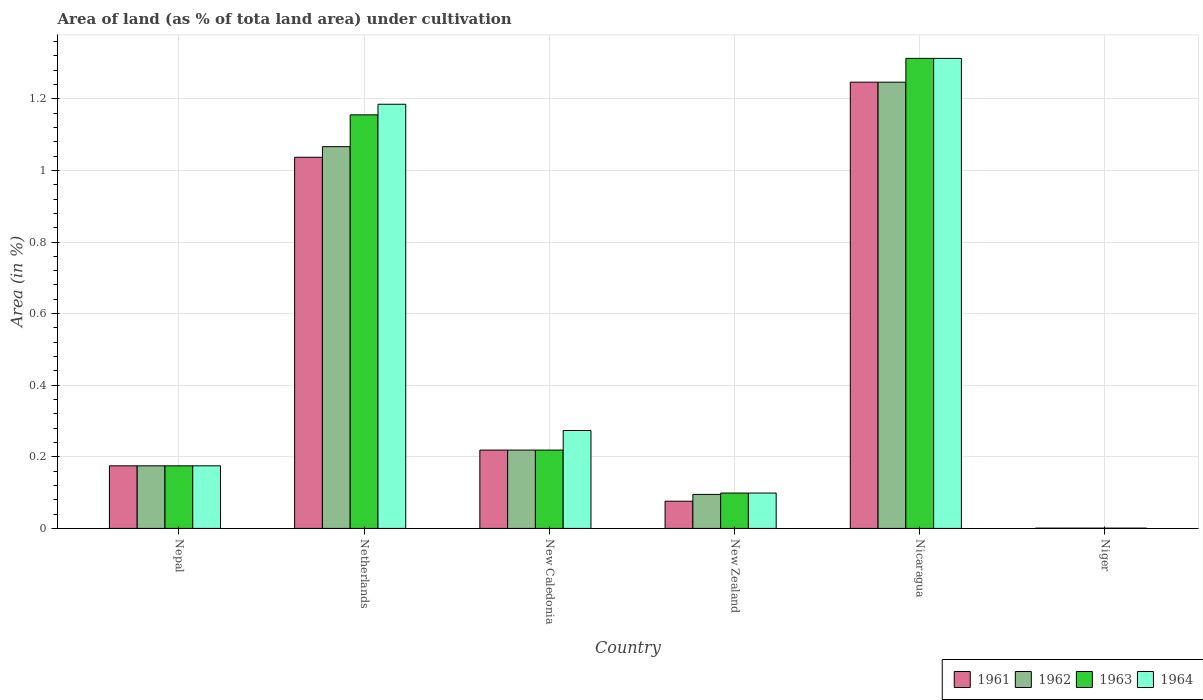How many groups of bars are there?
Make the answer very short. 6. Are the number of bars on each tick of the X-axis equal?
Ensure brevity in your answer.  Yes. How many bars are there on the 6th tick from the left?
Give a very brief answer. 4. How many bars are there on the 5th tick from the right?
Your answer should be compact. 4. What is the label of the 6th group of bars from the left?
Ensure brevity in your answer.  Niger. In how many cases, is the number of bars for a given country not equal to the number of legend labels?
Make the answer very short. 0. What is the percentage of land under cultivation in 1963 in New Caledonia?
Give a very brief answer. 0.22. Across all countries, what is the maximum percentage of land under cultivation in 1964?
Your answer should be compact. 1.31. Across all countries, what is the minimum percentage of land under cultivation in 1962?
Offer a very short reply. 0. In which country was the percentage of land under cultivation in 1961 maximum?
Give a very brief answer. Nicaragua. In which country was the percentage of land under cultivation in 1964 minimum?
Ensure brevity in your answer.  Niger. What is the total percentage of land under cultivation in 1963 in the graph?
Provide a short and direct response. 2.96. What is the difference between the percentage of land under cultivation in 1963 in Netherlands and that in New Caledonia?
Ensure brevity in your answer.  0.94. What is the difference between the percentage of land under cultivation in 1962 in Niger and the percentage of land under cultivation in 1961 in Nicaragua?
Give a very brief answer. -1.25. What is the average percentage of land under cultivation in 1962 per country?
Your response must be concise. 0.47. What is the difference between the percentage of land under cultivation of/in 1963 and percentage of land under cultivation of/in 1964 in New Caledonia?
Offer a very short reply. -0.05. What is the ratio of the percentage of land under cultivation in 1964 in Netherlands to that in New Zealand?
Make the answer very short. 12. Is the difference between the percentage of land under cultivation in 1963 in Nepal and New Caledonia greater than the difference between the percentage of land under cultivation in 1964 in Nepal and New Caledonia?
Your answer should be compact. Yes. What is the difference between the highest and the second highest percentage of land under cultivation in 1964?
Give a very brief answer. -1.04. What is the difference between the highest and the lowest percentage of land under cultivation in 1963?
Offer a very short reply. 1.31. In how many countries, is the percentage of land under cultivation in 1963 greater than the average percentage of land under cultivation in 1963 taken over all countries?
Make the answer very short. 2. What does the 1st bar from the right in Netherlands represents?
Keep it short and to the point. 1964. Is it the case that in every country, the sum of the percentage of land under cultivation in 1962 and percentage of land under cultivation in 1964 is greater than the percentage of land under cultivation in 1963?
Make the answer very short. Yes. How many bars are there?
Your answer should be very brief. 24. What is the difference between two consecutive major ticks on the Y-axis?
Keep it short and to the point. 0.2. Does the graph contain grids?
Provide a short and direct response. Yes. How many legend labels are there?
Offer a terse response. 4. How are the legend labels stacked?
Provide a succinct answer. Horizontal. What is the title of the graph?
Give a very brief answer. Area of land (as % of tota land area) under cultivation. Does "1986" appear as one of the legend labels in the graph?
Give a very brief answer. No. What is the label or title of the X-axis?
Keep it short and to the point. Country. What is the label or title of the Y-axis?
Offer a very short reply. Area (in %). What is the Area (in %) in 1961 in Nepal?
Offer a terse response. 0.17. What is the Area (in %) of 1962 in Nepal?
Your answer should be compact. 0.17. What is the Area (in %) of 1963 in Nepal?
Ensure brevity in your answer.  0.17. What is the Area (in %) in 1964 in Nepal?
Give a very brief answer. 0.17. What is the Area (in %) of 1961 in Netherlands?
Keep it short and to the point. 1.04. What is the Area (in %) in 1962 in Netherlands?
Your answer should be very brief. 1.07. What is the Area (in %) of 1963 in Netherlands?
Your answer should be very brief. 1.16. What is the Area (in %) of 1964 in Netherlands?
Your answer should be compact. 1.18. What is the Area (in %) of 1961 in New Caledonia?
Your answer should be very brief. 0.22. What is the Area (in %) in 1962 in New Caledonia?
Your answer should be compact. 0.22. What is the Area (in %) of 1963 in New Caledonia?
Ensure brevity in your answer.  0.22. What is the Area (in %) in 1964 in New Caledonia?
Provide a short and direct response. 0.27. What is the Area (in %) of 1961 in New Zealand?
Your answer should be very brief. 0.08. What is the Area (in %) in 1962 in New Zealand?
Your answer should be very brief. 0.09. What is the Area (in %) of 1963 in New Zealand?
Make the answer very short. 0.1. What is the Area (in %) of 1964 in New Zealand?
Provide a succinct answer. 0.1. What is the Area (in %) in 1961 in Nicaragua?
Ensure brevity in your answer.  1.25. What is the Area (in %) in 1962 in Nicaragua?
Provide a succinct answer. 1.25. What is the Area (in %) in 1963 in Nicaragua?
Provide a succinct answer. 1.31. What is the Area (in %) in 1964 in Nicaragua?
Your answer should be compact. 1.31. What is the Area (in %) in 1961 in Niger?
Offer a terse response. 0. What is the Area (in %) in 1962 in Niger?
Offer a very short reply. 0. What is the Area (in %) of 1963 in Niger?
Your response must be concise. 0. What is the Area (in %) in 1964 in Niger?
Keep it short and to the point. 0. Across all countries, what is the maximum Area (in %) in 1961?
Offer a very short reply. 1.25. Across all countries, what is the maximum Area (in %) in 1962?
Provide a short and direct response. 1.25. Across all countries, what is the maximum Area (in %) of 1963?
Ensure brevity in your answer.  1.31. Across all countries, what is the maximum Area (in %) in 1964?
Provide a short and direct response. 1.31. Across all countries, what is the minimum Area (in %) of 1961?
Keep it short and to the point. 0. Across all countries, what is the minimum Area (in %) in 1962?
Ensure brevity in your answer.  0. Across all countries, what is the minimum Area (in %) of 1963?
Make the answer very short. 0. Across all countries, what is the minimum Area (in %) of 1964?
Your answer should be compact. 0. What is the total Area (in %) in 1961 in the graph?
Make the answer very short. 2.75. What is the total Area (in %) of 1962 in the graph?
Offer a terse response. 2.8. What is the total Area (in %) of 1963 in the graph?
Your response must be concise. 2.96. What is the total Area (in %) in 1964 in the graph?
Keep it short and to the point. 3.05. What is the difference between the Area (in %) in 1961 in Nepal and that in Netherlands?
Make the answer very short. -0.86. What is the difference between the Area (in %) in 1962 in Nepal and that in Netherlands?
Offer a terse response. -0.89. What is the difference between the Area (in %) in 1963 in Nepal and that in Netherlands?
Ensure brevity in your answer.  -0.98. What is the difference between the Area (in %) in 1964 in Nepal and that in Netherlands?
Offer a terse response. -1.01. What is the difference between the Area (in %) in 1961 in Nepal and that in New Caledonia?
Make the answer very short. -0.04. What is the difference between the Area (in %) of 1962 in Nepal and that in New Caledonia?
Your response must be concise. -0.04. What is the difference between the Area (in %) in 1963 in Nepal and that in New Caledonia?
Give a very brief answer. -0.04. What is the difference between the Area (in %) in 1964 in Nepal and that in New Caledonia?
Provide a succinct answer. -0.1. What is the difference between the Area (in %) of 1961 in Nepal and that in New Zealand?
Offer a terse response. 0.1. What is the difference between the Area (in %) of 1962 in Nepal and that in New Zealand?
Your answer should be compact. 0.08. What is the difference between the Area (in %) of 1963 in Nepal and that in New Zealand?
Your answer should be compact. 0.08. What is the difference between the Area (in %) of 1964 in Nepal and that in New Zealand?
Keep it short and to the point. 0.08. What is the difference between the Area (in %) in 1961 in Nepal and that in Nicaragua?
Offer a terse response. -1.07. What is the difference between the Area (in %) in 1962 in Nepal and that in Nicaragua?
Offer a very short reply. -1.07. What is the difference between the Area (in %) of 1963 in Nepal and that in Nicaragua?
Provide a short and direct response. -1.14. What is the difference between the Area (in %) of 1964 in Nepal and that in Nicaragua?
Keep it short and to the point. -1.14. What is the difference between the Area (in %) of 1961 in Nepal and that in Niger?
Your response must be concise. 0.17. What is the difference between the Area (in %) of 1962 in Nepal and that in Niger?
Make the answer very short. 0.17. What is the difference between the Area (in %) of 1963 in Nepal and that in Niger?
Ensure brevity in your answer.  0.17. What is the difference between the Area (in %) in 1964 in Nepal and that in Niger?
Offer a terse response. 0.17. What is the difference between the Area (in %) in 1961 in Netherlands and that in New Caledonia?
Make the answer very short. 0.82. What is the difference between the Area (in %) of 1962 in Netherlands and that in New Caledonia?
Your answer should be compact. 0.85. What is the difference between the Area (in %) of 1963 in Netherlands and that in New Caledonia?
Keep it short and to the point. 0.94. What is the difference between the Area (in %) of 1964 in Netherlands and that in New Caledonia?
Your response must be concise. 0.91. What is the difference between the Area (in %) in 1961 in Netherlands and that in New Zealand?
Your response must be concise. 0.96. What is the difference between the Area (in %) in 1962 in Netherlands and that in New Zealand?
Give a very brief answer. 0.97. What is the difference between the Area (in %) in 1963 in Netherlands and that in New Zealand?
Keep it short and to the point. 1.06. What is the difference between the Area (in %) of 1964 in Netherlands and that in New Zealand?
Your response must be concise. 1.09. What is the difference between the Area (in %) in 1961 in Netherlands and that in Nicaragua?
Offer a very short reply. -0.21. What is the difference between the Area (in %) in 1962 in Netherlands and that in Nicaragua?
Keep it short and to the point. -0.18. What is the difference between the Area (in %) in 1963 in Netherlands and that in Nicaragua?
Your answer should be very brief. -0.16. What is the difference between the Area (in %) in 1964 in Netherlands and that in Nicaragua?
Your response must be concise. -0.13. What is the difference between the Area (in %) of 1961 in Netherlands and that in Niger?
Keep it short and to the point. 1.04. What is the difference between the Area (in %) in 1962 in Netherlands and that in Niger?
Offer a very short reply. 1.07. What is the difference between the Area (in %) in 1963 in Netherlands and that in Niger?
Keep it short and to the point. 1.15. What is the difference between the Area (in %) in 1964 in Netherlands and that in Niger?
Offer a terse response. 1.18. What is the difference between the Area (in %) of 1961 in New Caledonia and that in New Zealand?
Your answer should be very brief. 0.14. What is the difference between the Area (in %) in 1962 in New Caledonia and that in New Zealand?
Offer a very short reply. 0.12. What is the difference between the Area (in %) in 1963 in New Caledonia and that in New Zealand?
Keep it short and to the point. 0.12. What is the difference between the Area (in %) in 1964 in New Caledonia and that in New Zealand?
Provide a succinct answer. 0.17. What is the difference between the Area (in %) in 1961 in New Caledonia and that in Nicaragua?
Offer a terse response. -1.03. What is the difference between the Area (in %) of 1962 in New Caledonia and that in Nicaragua?
Provide a short and direct response. -1.03. What is the difference between the Area (in %) of 1963 in New Caledonia and that in Nicaragua?
Make the answer very short. -1.09. What is the difference between the Area (in %) in 1964 in New Caledonia and that in Nicaragua?
Provide a succinct answer. -1.04. What is the difference between the Area (in %) in 1961 in New Caledonia and that in Niger?
Ensure brevity in your answer.  0.22. What is the difference between the Area (in %) of 1962 in New Caledonia and that in Niger?
Give a very brief answer. 0.22. What is the difference between the Area (in %) in 1963 in New Caledonia and that in Niger?
Offer a terse response. 0.22. What is the difference between the Area (in %) in 1964 in New Caledonia and that in Niger?
Provide a succinct answer. 0.27. What is the difference between the Area (in %) of 1961 in New Zealand and that in Nicaragua?
Offer a very short reply. -1.17. What is the difference between the Area (in %) in 1962 in New Zealand and that in Nicaragua?
Ensure brevity in your answer.  -1.15. What is the difference between the Area (in %) of 1963 in New Zealand and that in Nicaragua?
Offer a terse response. -1.21. What is the difference between the Area (in %) of 1964 in New Zealand and that in Nicaragua?
Make the answer very short. -1.21. What is the difference between the Area (in %) of 1961 in New Zealand and that in Niger?
Keep it short and to the point. 0.08. What is the difference between the Area (in %) of 1962 in New Zealand and that in Niger?
Keep it short and to the point. 0.09. What is the difference between the Area (in %) in 1963 in New Zealand and that in Niger?
Your answer should be compact. 0.1. What is the difference between the Area (in %) of 1964 in New Zealand and that in Niger?
Offer a very short reply. 0.1. What is the difference between the Area (in %) in 1961 in Nicaragua and that in Niger?
Give a very brief answer. 1.25. What is the difference between the Area (in %) in 1962 in Nicaragua and that in Niger?
Make the answer very short. 1.25. What is the difference between the Area (in %) of 1963 in Nicaragua and that in Niger?
Offer a terse response. 1.31. What is the difference between the Area (in %) in 1964 in Nicaragua and that in Niger?
Your answer should be very brief. 1.31. What is the difference between the Area (in %) in 1961 in Nepal and the Area (in %) in 1962 in Netherlands?
Offer a very short reply. -0.89. What is the difference between the Area (in %) of 1961 in Nepal and the Area (in %) of 1963 in Netherlands?
Keep it short and to the point. -0.98. What is the difference between the Area (in %) in 1961 in Nepal and the Area (in %) in 1964 in Netherlands?
Offer a very short reply. -1.01. What is the difference between the Area (in %) in 1962 in Nepal and the Area (in %) in 1963 in Netherlands?
Offer a terse response. -0.98. What is the difference between the Area (in %) of 1962 in Nepal and the Area (in %) of 1964 in Netherlands?
Make the answer very short. -1.01. What is the difference between the Area (in %) of 1963 in Nepal and the Area (in %) of 1964 in Netherlands?
Provide a short and direct response. -1.01. What is the difference between the Area (in %) of 1961 in Nepal and the Area (in %) of 1962 in New Caledonia?
Your answer should be compact. -0.04. What is the difference between the Area (in %) of 1961 in Nepal and the Area (in %) of 1963 in New Caledonia?
Your answer should be compact. -0.04. What is the difference between the Area (in %) in 1961 in Nepal and the Area (in %) in 1964 in New Caledonia?
Your response must be concise. -0.1. What is the difference between the Area (in %) in 1962 in Nepal and the Area (in %) in 1963 in New Caledonia?
Provide a short and direct response. -0.04. What is the difference between the Area (in %) in 1962 in Nepal and the Area (in %) in 1964 in New Caledonia?
Give a very brief answer. -0.1. What is the difference between the Area (in %) of 1963 in Nepal and the Area (in %) of 1964 in New Caledonia?
Your response must be concise. -0.1. What is the difference between the Area (in %) of 1961 in Nepal and the Area (in %) of 1962 in New Zealand?
Keep it short and to the point. 0.08. What is the difference between the Area (in %) in 1961 in Nepal and the Area (in %) in 1963 in New Zealand?
Provide a succinct answer. 0.08. What is the difference between the Area (in %) in 1961 in Nepal and the Area (in %) in 1964 in New Zealand?
Offer a terse response. 0.08. What is the difference between the Area (in %) of 1962 in Nepal and the Area (in %) of 1963 in New Zealand?
Ensure brevity in your answer.  0.08. What is the difference between the Area (in %) in 1962 in Nepal and the Area (in %) in 1964 in New Zealand?
Offer a terse response. 0.08. What is the difference between the Area (in %) of 1963 in Nepal and the Area (in %) of 1964 in New Zealand?
Provide a succinct answer. 0.08. What is the difference between the Area (in %) of 1961 in Nepal and the Area (in %) of 1962 in Nicaragua?
Your answer should be compact. -1.07. What is the difference between the Area (in %) of 1961 in Nepal and the Area (in %) of 1963 in Nicaragua?
Give a very brief answer. -1.14. What is the difference between the Area (in %) of 1961 in Nepal and the Area (in %) of 1964 in Nicaragua?
Ensure brevity in your answer.  -1.14. What is the difference between the Area (in %) of 1962 in Nepal and the Area (in %) of 1963 in Nicaragua?
Your answer should be very brief. -1.14. What is the difference between the Area (in %) in 1962 in Nepal and the Area (in %) in 1964 in Nicaragua?
Your response must be concise. -1.14. What is the difference between the Area (in %) in 1963 in Nepal and the Area (in %) in 1964 in Nicaragua?
Ensure brevity in your answer.  -1.14. What is the difference between the Area (in %) in 1961 in Nepal and the Area (in %) in 1962 in Niger?
Ensure brevity in your answer.  0.17. What is the difference between the Area (in %) of 1961 in Nepal and the Area (in %) of 1963 in Niger?
Your response must be concise. 0.17. What is the difference between the Area (in %) of 1961 in Nepal and the Area (in %) of 1964 in Niger?
Provide a succinct answer. 0.17. What is the difference between the Area (in %) in 1962 in Nepal and the Area (in %) in 1963 in Niger?
Provide a succinct answer. 0.17. What is the difference between the Area (in %) of 1962 in Nepal and the Area (in %) of 1964 in Niger?
Your answer should be compact. 0.17. What is the difference between the Area (in %) of 1963 in Nepal and the Area (in %) of 1964 in Niger?
Offer a very short reply. 0.17. What is the difference between the Area (in %) in 1961 in Netherlands and the Area (in %) in 1962 in New Caledonia?
Keep it short and to the point. 0.82. What is the difference between the Area (in %) in 1961 in Netherlands and the Area (in %) in 1963 in New Caledonia?
Provide a short and direct response. 0.82. What is the difference between the Area (in %) in 1961 in Netherlands and the Area (in %) in 1964 in New Caledonia?
Offer a very short reply. 0.76. What is the difference between the Area (in %) in 1962 in Netherlands and the Area (in %) in 1963 in New Caledonia?
Keep it short and to the point. 0.85. What is the difference between the Area (in %) of 1962 in Netherlands and the Area (in %) of 1964 in New Caledonia?
Offer a very short reply. 0.79. What is the difference between the Area (in %) of 1963 in Netherlands and the Area (in %) of 1964 in New Caledonia?
Your answer should be very brief. 0.88. What is the difference between the Area (in %) of 1961 in Netherlands and the Area (in %) of 1962 in New Zealand?
Ensure brevity in your answer.  0.94. What is the difference between the Area (in %) in 1961 in Netherlands and the Area (in %) in 1963 in New Zealand?
Offer a terse response. 0.94. What is the difference between the Area (in %) of 1961 in Netherlands and the Area (in %) of 1964 in New Zealand?
Keep it short and to the point. 0.94. What is the difference between the Area (in %) of 1962 in Netherlands and the Area (in %) of 1963 in New Zealand?
Make the answer very short. 0.97. What is the difference between the Area (in %) of 1962 in Netherlands and the Area (in %) of 1964 in New Zealand?
Your answer should be compact. 0.97. What is the difference between the Area (in %) of 1963 in Netherlands and the Area (in %) of 1964 in New Zealand?
Provide a succinct answer. 1.06. What is the difference between the Area (in %) in 1961 in Netherlands and the Area (in %) in 1962 in Nicaragua?
Provide a short and direct response. -0.21. What is the difference between the Area (in %) in 1961 in Netherlands and the Area (in %) in 1963 in Nicaragua?
Provide a short and direct response. -0.28. What is the difference between the Area (in %) of 1961 in Netherlands and the Area (in %) of 1964 in Nicaragua?
Your response must be concise. -0.28. What is the difference between the Area (in %) of 1962 in Netherlands and the Area (in %) of 1963 in Nicaragua?
Your answer should be very brief. -0.25. What is the difference between the Area (in %) of 1962 in Netherlands and the Area (in %) of 1964 in Nicaragua?
Your response must be concise. -0.25. What is the difference between the Area (in %) in 1963 in Netherlands and the Area (in %) in 1964 in Nicaragua?
Your answer should be compact. -0.16. What is the difference between the Area (in %) of 1961 in Netherlands and the Area (in %) of 1962 in Niger?
Keep it short and to the point. 1.04. What is the difference between the Area (in %) in 1961 in Netherlands and the Area (in %) in 1963 in Niger?
Provide a succinct answer. 1.04. What is the difference between the Area (in %) in 1961 in Netherlands and the Area (in %) in 1964 in Niger?
Provide a short and direct response. 1.04. What is the difference between the Area (in %) in 1962 in Netherlands and the Area (in %) in 1963 in Niger?
Give a very brief answer. 1.07. What is the difference between the Area (in %) in 1962 in Netherlands and the Area (in %) in 1964 in Niger?
Give a very brief answer. 1.07. What is the difference between the Area (in %) of 1963 in Netherlands and the Area (in %) of 1964 in Niger?
Make the answer very short. 1.15. What is the difference between the Area (in %) in 1961 in New Caledonia and the Area (in %) in 1962 in New Zealand?
Ensure brevity in your answer.  0.12. What is the difference between the Area (in %) in 1961 in New Caledonia and the Area (in %) in 1963 in New Zealand?
Offer a terse response. 0.12. What is the difference between the Area (in %) in 1961 in New Caledonia and the Area (in %) in 1964 in New Zealand?
Offer a very short reply. 0.12. What is the difference between the Area (in %) of 1962 in New Caledonia and the Area (in %) of 1963 in New Zealand?
Ensure brevity in your answer.  0.12. What is the difference between the Area (in %) of 1962 in New Caledonia and the Area (in %) of 1964 in New Zealand?
Make the answer very short. 0.12. What is the difference between the Area (in %) in 1963 in New Caledonia and the Area (in %) in 1964 in New Zealand?
Make the answer very short. 0.12. What is the difference between the Area (in %) of 1961 in New Caledonia and the Area (in %) of 1962 in Nicaragua?
Your response must be concise. -1.03. What is the difference between the Area (in %) of 1961 in New Caledonia and the Area (in %) of 1963 in Nicaragua?
Provide a succinct answer. -1.09. What is the difference between the Area (in %) in 1961 in New Caledonia and the Area (in %) in 1964 in Nicaragua?
Your response must be concise. -1.09. What is the difference between the Area (in %) in 1962 in New Caledonia and the Area (in %) in 1963 in Nicaragua?
Your response must be concise. -1.09. What is the difference between the Area (in %) in 1962 in New Caledonia and the Area (in %) in 1964 in Nicaragua?
Offer a terse response. -1.09. What is the difference between the Area (in %) of 1963 in New Caledonia and the Area (in %) of 1964 in Nicaragua?
Make the answer very short. -1.09. What is the difference between the Area (in %) of 1961 in New Caledonia and the Area (in %) of 1962 in Niger?
Provide a short and direct response. 0.22. What is the difference between the Area (in %) of 1961 in New Caledonia and the Area (in %) of 1963 in Niger?
Keep it short and to the point. 0.22. What is the difference between the Area (in %) of 1961 in New Caledonia and the Area (in %) of 1964 in Niger?
Your answer should be very brief. 0.22. What is the difference between the Area (in %) in 1962 in New Caledonia and the Area (in %) in 1963 in Niger?
Ensure brevity in your answer.  0.22. What is the difference between the Area (in %) in 1962 in New Caledonia and the Area (in %) in 1964 in Niger?
Offer a terse response. 0.22. What is the difference between the Area (in %) of 1963 in New Caledonia and the Area (in %) of 1964 in Niger?
Your response must be concise. 0.22. What is the difference between the Area (in %) of 1961 in New Zealand and the Area (in %) of 1962 in Nicaragua?
Ensure brevity in your answer.  -1.17. What is the difference between the Area (in %) of 1961 in New Zealand and the Area (in %) of 1963 in Nicaragua?
Make the answer very short. -1.24. What is the difference between the Area (in %) in 1961 in New Zealand and the Area (in %) in 1964 in Nicaragua?
Provide a succinct answer. -1.24. What is the difference between the Area (in %) in 1962 in New Zealand and the Area (in %) in 1963 in Nicaragua?
Give a very brief answer. -1.22. What is the difference between the Area (in %) in 1962 in New Zealand and the Area (in %) in 1964 in Nicaragua?
Ensure brevity in your answer.  -1.22. What is the difference between the Area (in %) in 1963 in New Zealand and the Area (in %) in 1964 in Nicaragua?
Keep it short and to the point. -1.21. What is the difference between the Area (in %) of 1961 in New Zealand and the Area (in %) of 1962 in Niger?
Ensure brevity in your answer.  0.08. What is the difference between the Area (in %) of 1961 in New Zealand and the Area (in %) of 1963 in Niger?
Give a very brief answer. 0.08. What is the difference between the Area (in %) in 1961 in New Zealand and the Area (in %) in 1964 in Niger?
Your answer should be very brief. 0.08. What is the difference between the Area (in %) in 1962 in New Zealand and the Area (in %) in 1963 in Niger?
Offer a terse response. 0.09. What is the difference between the Area (in %) in 1962 in New Zealand and the Area (in %) in 1964 in Niger?
Provide a succinct answer. 0.09. What is the difference between the Area (in %) in 1963 in New Zealand and the Area (in %) in 1964 in Niger?
Offer a very short reply. 0.1. What is the difference between the Area (in %) of 1961 in Nicaragua and the Area (in %) of 1962 in Niger?
Make the answer very short. 1.25. What is the difference between the Area (in %) in 1961 in Nicaragua and the Area (in %) in 1963 in Niger?
Your response must be concise. 1.25. What is the difference between the Area (in %) in 1961 in Nicaragua and the Area (in %) in 1964 in Niger?
Offer a very short reply. 1.25. What is the difference between the Area (in %) of 1962 in Nicaragua and the Area (in %) of 1963 in Niger?
Your answer should be compact. 1.25. What is the difference between the Area (in %) of 1962 in Nicaragua and the Area (in %) of 1964 in Niger?
Provide a succinct answer. 1.25. What is the difference between the Area (in %) of 1963 in Nicaragua and the Area (in %) of 1964 in Niger?
Make the answer very short. 1.31. What is the average Area (in %) in 1961 per country?
Provide a succinct answer. 0.46. What is the average Area (in %) of 1962 per country?
Your answer should be compact. 0.47. What is the average Area (in %) in 1963 per country?
Keep it short and to the point. 0.49. What is the average Area (in %) of 1964 per country?
Ensure brevity in your answer.  0.51. What is the difference between the Area (in %) of 1961 and Area (in %) of 1962 in Nepal?
Make the answer very short. 0. What is the difference between the Area (in %) in 1961 and Area (in %) in 1964 in Nepal?
Keep it short and to the point. 0. What is the difference between the Area (in %) of 1963 and Area (in %) of 1964 in Nepal?
Ensure brevity in your answer.  0. What is the difference between the Area (in %) of 1961 and Area (in %) of 1962 in Netherlands?
Offer a very short reply. -0.03. What is the difference between the Area (in %) in 1961 and Area (in %) in 1963 in Netherlands?
Provide a short and direct response. -0.12. What is the difference between the Area (in %) in 1961 and Area (in %) in 1964 in Netherlands?
Offer a very short reply. -0.15. What is the difference between the Area (in %) in 1962 and Area (in %) in 1963 in Netherlands?
Offer a very short reply. -0.09. What is the difference between the Area (in %) in 1962 and Area (in %) in 1964 in Netherlands?
Your response must be concise. -0.12. What is the difference between the Area (in %) of 1963 and Area (in %) of 1964 in Netherlands?
Your answer should be compact. -0.03. What is the difference between the Area (in %) of 1961 and Area (in %) of 1963 in New Caledonia?
Give a very brief answer. 0. What is the difference between the Area (in %) of 1961 and Area (in %) of 1964 in New Caledonia?
Keep it short and to the point. -0.05. What is the difference between the Area (in %) of 1962 and Area (in %) of 1963 in New Caledonia?
Your response must be concise. 0. What is the difference between the Area (in %) in 1962 and Area (in %) in 1964 in New Caledonia?
Offer a very short reply. -0.05. What is the difference between the Area (in %) in 1963 and Area (in %) in 1964 in New Caledonia?
Your answer should be compact. -0.05. What is the difference between the Area (in %) in 1961 and Area (in %) in 1962 in New Zealand?
Keep it short and to the point. -0.02. What is the difference between the Area (in %) of 1961 and Area (in %) of 1963 in New Zealand?
Your answer should be very brief. -0.02. What is the difference between the Area (in %) of 1961 and Area (in %) of 1964 in New Zealand?
Keep it short and to the point. -0.02. What is the difference between the Area (in %) of 1962 and Area (in %) of 1963 in New Zealand?
Offer a terse response. -0. What is the difference between the Area (in %) in 1962 and Area (in %) in 1964 in New Zealand?
Provide a short and direct response. -0. What is the difference between the Area (in %) of 1963 and Area (in %) of 1964 in New Zealand?
Offer a very short reply. 0. What is the difference between the Area (in %) of 1961 and Area (in %) of 1962 in Nicaragua?
Your response must be concise. 0. What is the difference between the Area (in %) of 1961 and Area (in %) of 1963 in Nicaragua?
Offer a very short reply. -0.07. What is the difference between the Area (in %) of 1961 and Area (in %) of 1964 in Nicaragua?
Provide a short and direct response. -0.07. What is the difference between the Area (in %) of 1962 and Area (in %) of 1963 in Nicaragua?
Offer a terse response. -0.07. What is the difference between the Area (in %) in 1962 and Area (in %) in 1964 in Nicaragua?
Your response must be concise. -0.07. What is the difference between the Area (in %) of 1961 and Area (in %) of 1963 in Niger?
Your response must be concise. 0. What is the difference between the Area (in %) in 1962 and Area (in %) in 1963 in Niger?
Make the answer very short. 0. What is the ratio of the Area (in %) of 1961 in Nepal to that in Netherlands?
Offer a very short reply. 0.17. What is the ratio of the Area (in %) of 1962 in Nepal to that in Netherlands?
Provide a short and direct response. 0.16. What is the ratio of the Area (in %) in 1963 in Nepal to that in Netherlands?
Give a very brief answer. 0.15. What is the ratio of the Area (in %) in 1964 in Nepal to that in Netherlands?
Ensure brevity in your answer.  0.15. What is the ratio of the Area (in %) in 1961 in Nepal to that in New Caledonia?
Your answer should be compact. 0.8. What is the ratio of the Area (in %) of 1962 in Nepal to that in New Caledonia?
Your answer should be compact. 0.8. What is the ratio of the Area (in %) in 1963 in Nepal to that in New Caledonia?
Offer a very short reply. 0.8. What is the ratio of the Area (in %) in 1964 in Nepal to that in New Caledonia?
Give a very brief answer. 0.64. What is the ratio of the Area (in %) in 1961 in Nepal to that in New Zealand?
Your answer should be compact. 2.3. What is the ratio of the Area (in %) of 1962 in Nepal to that in New Zealand?
Keep it short and to the point. 1.84. What is the ratio of the Area (in %) of 1963 in Nepal to that in New Zealand?
Your answer should be compact. 1.77. What is the ratio of the Area (in %) in 1964 in Nepal to that in New Zealand?
Ensure brevity in your answer.  1.77. What is the ratio of the Area (in %) in 1961 in Nepal to that in Nicaragua?
Give a very brief answer. 0.14. What is the ratio of the Area (in %) of 1962 in Nepal to that in Nicaragua?
Give a very brief answer. 0.14. What is the ratio of the Area (in %) of 1963 in Nepal to that in Nicaragua?
Keep it short and to the point. 0.13. What is the ratio of the Area (in %) of 1964 in Nepal to that in Nicaragua?
Provide a short and direct response. 0.13. What is the ratio of the Area (in %) in 1961 in Nepal to that in Niger?
Offer a very short reply. 221.45. What is the ratio of the Area (in %) of 1962 in Nepal to that in Niger?
Make the answer very short. 221.45. What is the ratio of the Area (in %) in 1963 in Nepal to that in Niger?
Your response must be concise. 221.45. What is the ratio of the Area (in %) in 1964 in Nepal to that in Niger?
Offer a terse response. 221.45. What is the ratio of the Area (in %) in 1961 in Netherlands to that in New Caledonia?
Your answer should be compact. 4.74. What is the ratio of the Area (in %) of 1962 in Netherlands to that in New Caledonia?
Your response must be concise. 4.87. What is the ratio of the Area (in %) in 1963 in Netherlands to that in New Caledonia?
Ensure brevity in your answer.  5.28. What is the ratio of the Area (in %) in 1964 in Netherlands to that in New Caledonia?
Make the answer very short. 4.33. What is the ratio of the Area (in %) of 1961 in Netherlands to that in New Zealand?
Offer a terse response. 13.65. What is the ratio of the Area (in %) of 1962 in Netherlands to that in New Zealand?
Ensure brevity in your answer.  11.23. What is the ratio of the Area (in %) of 1963 in Netherlands to that in New Zealand?
Make the answer very short. 11.7. What is the ratio of the Area (in %) in 1964 in Netherlands to that in New Zealand?
Your response must be concise. 12. What is the ratio of the Area (in %) of 1961 in Netherlands to that in Nicaragua?
Offer a very short reply. 0.83. What is the ratio of the Area (in %) in 1962 in Netherlands to that in Nicaragua?
Ensure brevity in your answer.  0.86. What is the ratio of the Area (in %) in 1963 in Netherlands to that in Nicaragua?
Offer a terse response. 0.88. What is the ratio of the Area (in %) of 1964 in Netherlands to that in Nicaragua?
Your answer should be compact. 0.9. What is the ratio of the Area (in %) in 1961 in Netherlands to that in Niger?
Provide a short and direct response. 1313.23. What is the ratio of the Area (in %) of 1962 in Netherlands to that in Niger?
Offer a terse response. 1350.75. What is the ratio of the Area (in %) of 1963 in Netherlands to that in Niger?
Your answer should be very brief. 1463.31. What is the ratio of the Area (in %) in 1964 in Netherlands to that in Niger?
Make the answer very short. 1500.83. What is the ratio of the Area (in %) in 1961 in New Caledonia to that in New Zealand?
Keep it short and to the point. 2.88. What is the ratio of the Area (in %) in 1962 in New Caledonia to that in New Zealand?
Give a very brief answer. 2.3. What is the ratio of the Area (in %) in 1963 in New Caledonia to that in New Zealand?
Your response must be concise. 2.22. What is the ratio of the Area (in %) of 1964 in New Caledonia to that in New Zealand?
Offer a very short reply. 2.77. What is the ratio of the Area (in %) of 1961 in New Caledonia to that in Nicaragua?
Offer a very short reply. 0.18. What is the ratio of the Area (in %) of 1962 in New Caledonia to that in Nicaragua?
Offer a very short reply. 0.18. What is the ratio of the Area (in %) of 1964 in New Caledonia to that in Nicaragua?
Offer a very short reply. 0.21. What is the ratio of the Area (in %) in 1961 in New Caledonia to that in Niger?
Your answer should be compact. 277.18. What is the ratio of the Area (in %) of 1962 in New Caledonia to that in Niger?
Keep it short and to the point. 277.18. What is the ratio of the Area (in %) in 1963 in New Caledonia to that in Niger?
Provide a short and direct response. 277.18. What is the ratio of the Area (in %) in 1964 in New Caledonia to that in Niger?
Make the answer very short. 346.47. What is the ratio of the Area (in %) in 1961 in New Zealand to that in Nicaragua?
Your answer should be very brief. 0.06. What is the ratio of the Area (in %) in 1962 in New Zealand to that in Nicaragua?
Your response must be concise. 0.08. What is the ratio of the Area (in %) of 1963 in New Zealand to that in Nicaragua?
Provide a succinct answer. 0.08. What is the ratio of the Area (in %) of 1964 in New Zealand to that in Nicaragua?
Offer a very short reply. 0.08. What is the ratio of the Area (in %) in 1961 in New Zealand to that in Niger?
Offer a very short reply. 96.21. What is the ratio of the Area (in %) in 1962 in New Zealand to that in Niger?
Ensure brevity in your answer.  120.27. What is the ratio of the Area (in %) in 1963 in New Zealand to that in Niger?
Offer a terse response. 125.08. What is the ratio of the Area (in %) of 1964 in New Zealand to that in Niger?
Ensure brevity in your answer.  125.08. What is the ratio of the Area (in %) in 1961 in Nicaragua to that in Niger?
Offer a terse response. 1578.9. What is the ratio of the Area (in %) of 1962 in Nicaragua to that in Niger?
Your answer should be very brief. 1578.9. What is the ratio of the Area (in %) of 1963 in Nicaragua to that in Niger?
Your response must be concise. 1663.11. What is the ratio of the Area (in %) of 1964 in Nicaragua to that in Niger?
Offer a very short reply. 1663.11. What is the difference between the highest and the second highest Area (in %) in 1961?
Offer a very short reply. 0.21. What is the difference between the highest and the second highest Area (in %) of 1962?
Your answer should be compact. 0.18. What is the difference between the highest and the second highest Area (in %) of 1963?
Give a very brief answer. 0.16. What is the difference between the highest and the second highest Area (in %) of 1964?
Keep it short and to the point. 0.13. What is the difference between the highest and the lowest Area (in %) in 1961?
Provide a succinct answer. 1.25. What is the difference between the highest and the lowest Area (in %) of 1962?
Your response must be concise. 1.25. What is the difference between the highest and the lowest Area (in %) in 1963?
Provide a succinct answer. 1.31. What is the difference between the highest and the lowest Area (in %) of 1964?
Offer a very short reply. 1.31. 